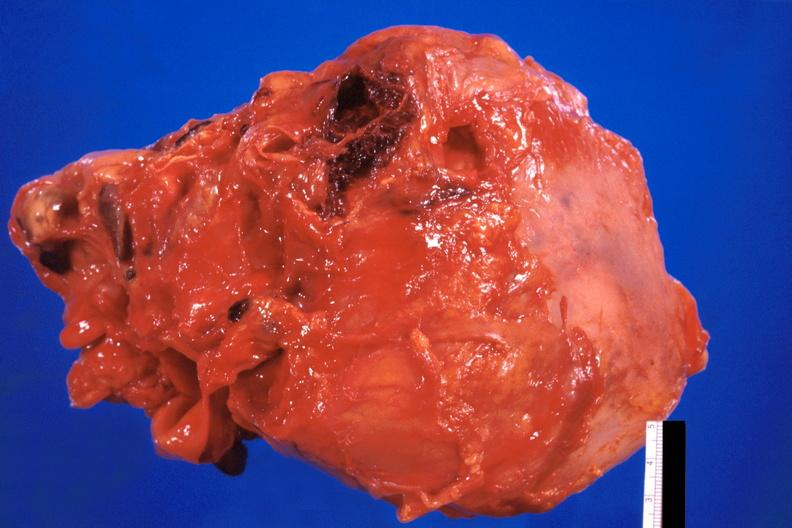what does this image show?
Answer the question using a single word or phrase. Pericarditis 